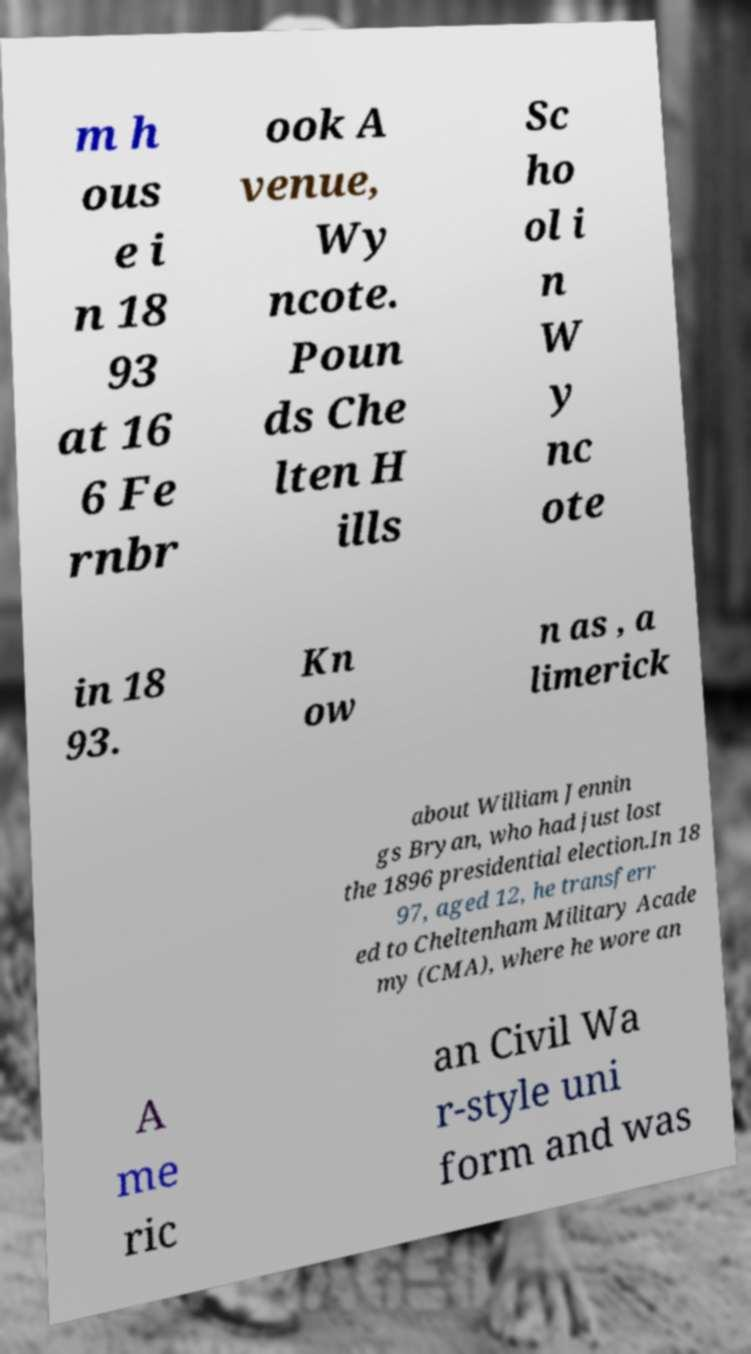Could you extract and type out the text from this image? m h ous e i n 18 93 at 16 6 Fe rnbr ook A venue, Wy ncote. Poun ds Che lten H ills Sc ho ol i n W y nc ote in 18 93. Kn ow n as , a limerick about William Jennin gs Bryan, who had just lost the 1896 presidential election.In 18 97, aged 12, he transferr ed to Cheltenham Military Acade my (CMA), where he wore an A me ric an Civil Wa r-style uni form and was 